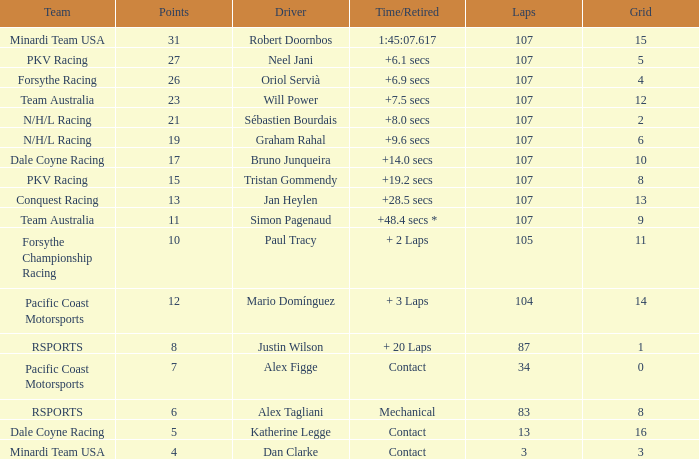What is mario domínguez's average Grid? 14.0. 